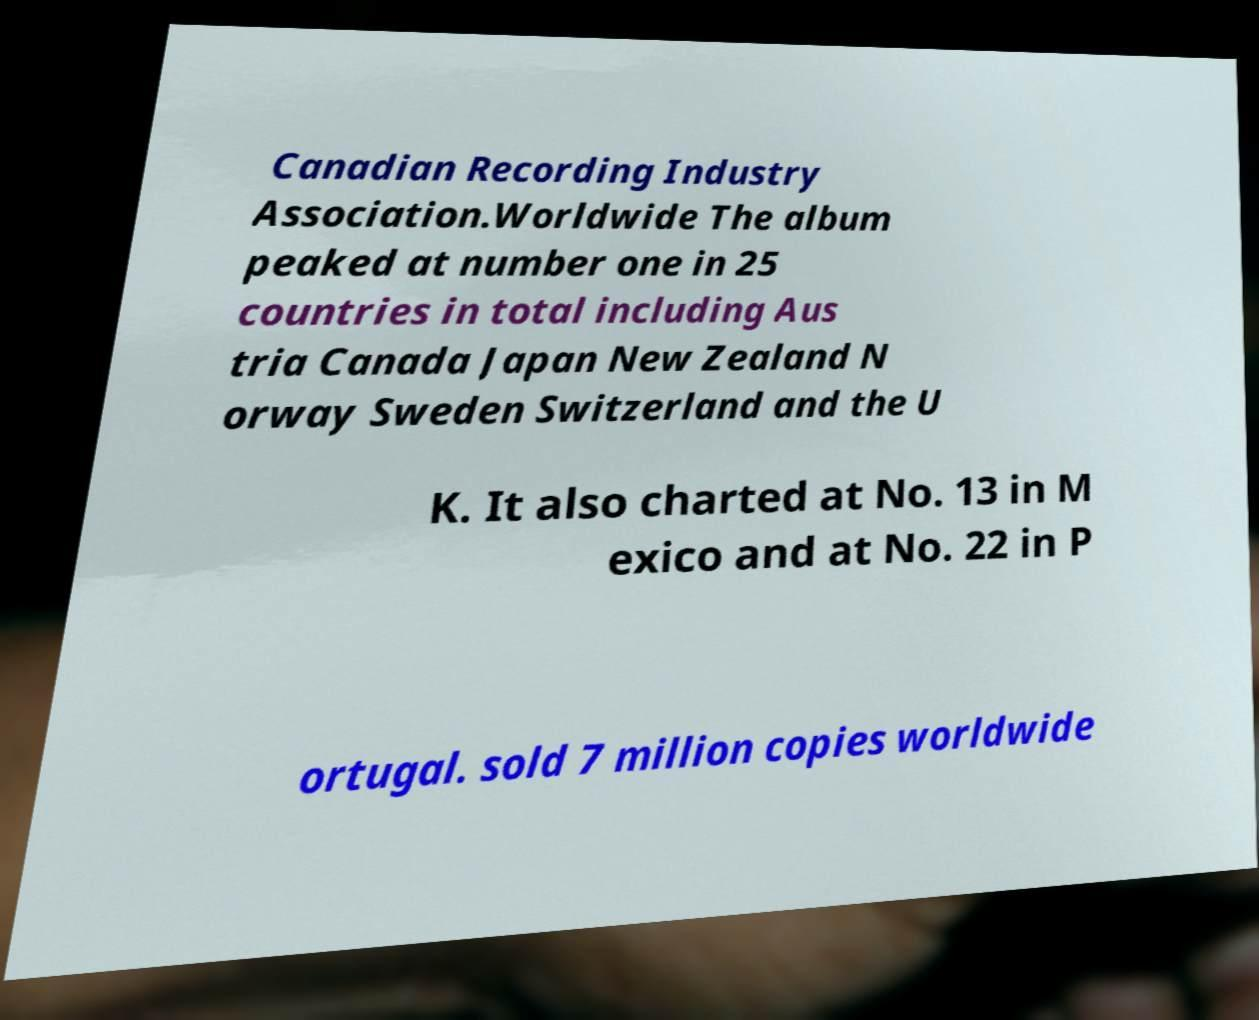Could you assist in decoding the text presented in this image and type it out clearly? Canadian Recording Industry Association.Worldwide The album peaked at number one in 25 countries in total including Aus tria Canada Japan New Zealand N orway Sweden Switzerland and the U K. It also charted at No. 13 in M exico and at No. 22 in P ortugal. sold 7 million copies worldwide 